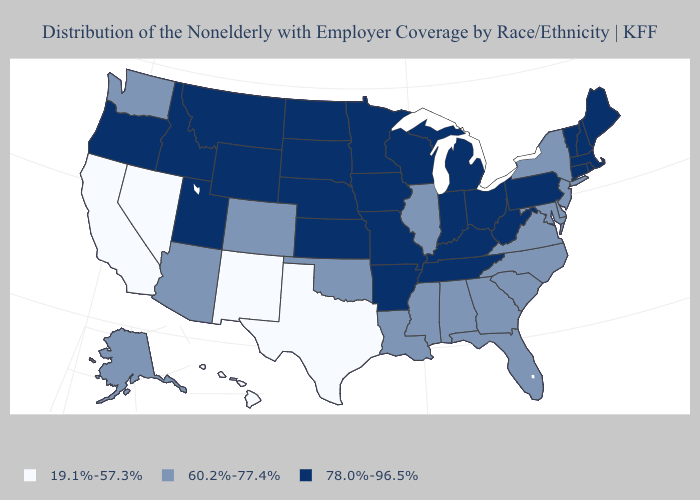Name the states that have a value in the range 78.0%-96.5%?
Short answer required. Arkansas, Connecticut, Idaho, Indiana, Iowa, Kansas, Kentucky, Maine, Massachusetts, Michigan, Minnesota, Missouri, Montana, Nebraska, New Hampshire, North Dakota, Ohio, Oregon, Pennsylvania, Rhode Island, South Dakota, Tennessee, Utah, Vermont, West Virginia, Wisconsin, Wyoming. Name the states that have a value in the range 78.0%-96.5%?
Write a very short answer. Arkansas, Connecticut, Idaho, Indiana, Iowa, Kansas, Kentucky, Maine, Massachusetts, Michigan, Minnesota, Missouri, Montana, Nebraska, New Hampshire, North Dakota, Ohio, Oregon, Pennsylvania, Rhode Island, South Dakota, Tennessee, Utah, Vermont, West Virginia, Wisconsin, Wyoming. What is the lowest value in the South?
Write a very short answer. 19.1%-57.3%. What is the value of Virginia?
Answer briefly. 60.2%-77.4%. What is the value of Colorado?
Quick response, please. 60.2%-77.4%. Does Rhode Island have the lowest value in the Northeast?
Keep it brief. No. Does New Mexico have the highest value in the West?
Keep it brief. No. What is the value of Washington?
Keep it brief. 60.2%-77.4%. Name the states that have a value in the range 60.2%-77.4%?
Write a very short answer. Alabama, Alaska, Arizona, Colorado, Delaware, Florida, Georgia, Illinois, Louisiana, Maryland, Mississippi, New Jersey, New York, North Carolina, Oklahoma, South Carolina, Virginia, Washington. Among the states that border Nevada , does California have the highest value?
Keep it brief. No. What is the value of Louisiana?
Write a very short answer. 60.2%-77.4%. What is the value of Maryland?
Short answer required. 60.2%-77.4%. Name the states that have a value in the range 60.2%-77.4%?
Give a very brief answer. Alabama, Alaska, Arizona, Colorado, Delaware, Florida, Georgia, Illinois, Louisiana, Maryland, Mississippi, New Jersey, New York, North Carolina, Oklahoma, South Carolina, Virginia, Washington. Does the first symbol in the legend represent the smallest category?
Short answer required. Yes. Does Kansas have the same value as Florida?
Give a very brief answer. No. 